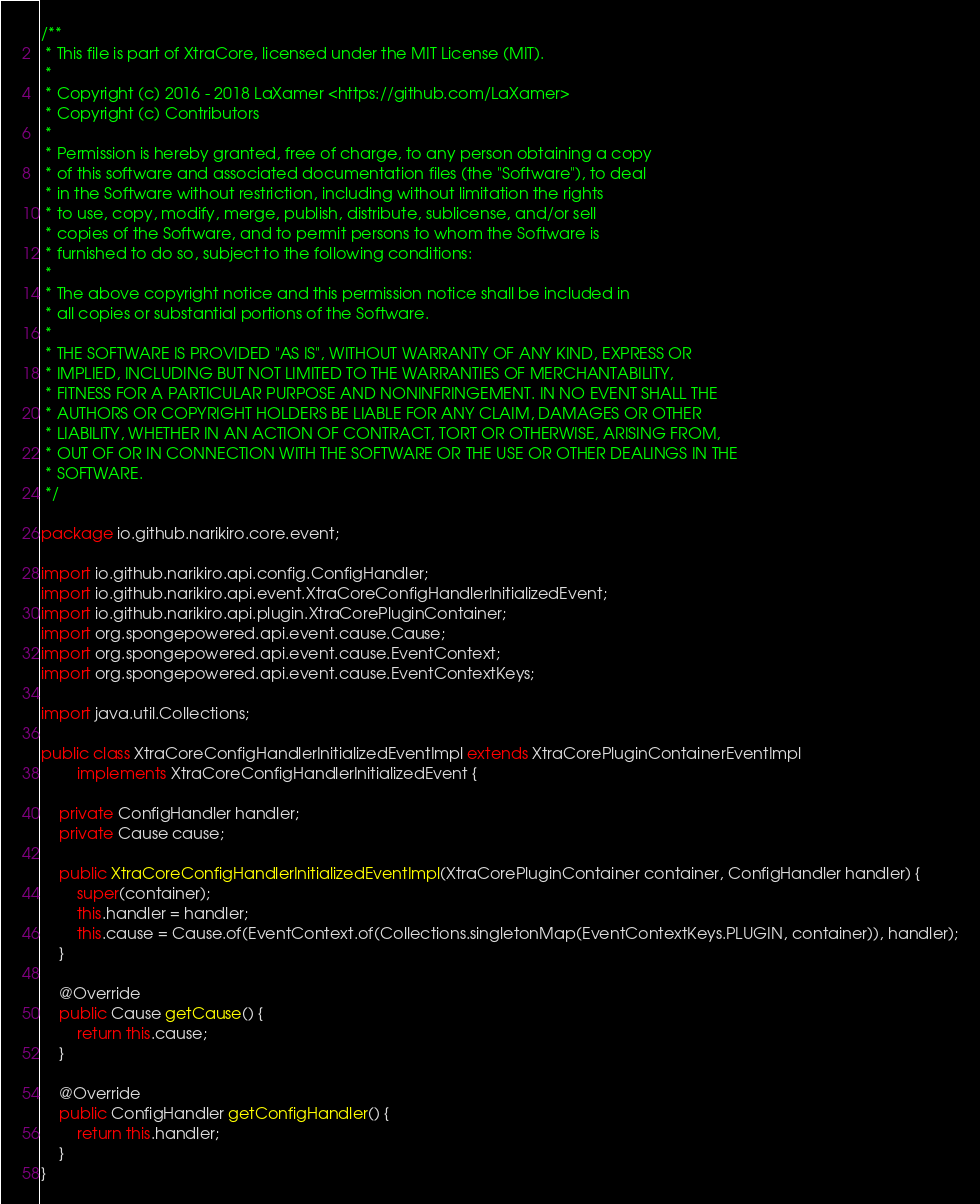Convert code to text. <code><loc_0><loc_0><loc_500><loc_500><_Java_>/**
 * This file is part of XtraCore, licensed under the MIT License (MIT).
 *
 * Copyright (c) 2016 - 2018 LaXamer <https://github.com/LaXamer>
 * Copyright (c) Contributors
 *
 * Permission is hereby granted, free of charge, to any person obtaining a copy
 * of this software and associated documentation files (the "Software"), to deal
 * in the Software without restriction, including without limitation the rights
 * to use, copy, modify, merge, publish, distribute, sublicense, and/or sell
 * copies of the Software, and to permit persons to whom the Software is
 * furnished to do so, subject to the following conditions:
 *
 * The above copyright notice and this permission notice shall be included in
 * all copies or substantial portions of the Software.
 *
 * THE SOFTWARE IS PROVIDED "AS IS", WITHOUT WARRANTY OF ANY KIND, EXPRESS OR
 * IMPLIED, INCLUDING BUT NOT LIMITED TO THE WARRANTIES OF MERCHANTABILITY,
 * FITNESS FOR A PARTICULAR PURPOSE AND NONINFRINGEMENT. IN NO EVENT SHALL THE
 * AUTHORS OR COPYRIGHT HOLDERS BE LIABLE FOR ANY CLAIM, DAMAGES OR OTHER
 * LIABILITY, WHETHER IN AN ACTION OF CONTRACT, TORT OR OTHERWISE, ARISING FROM,
 * OUT OF OR IN CONNECTION WITH THE SOFTWARE OR THE USE OR OTHER DEALINGS IN THE
 * SOFTWARE.
 */

package io.github.narikiro.core.event;

import io.github.narikiro.api.config.ConfigHandler;
import io.github.narikiro.api.event.XtraCoreConfigHandlerInitializedEvent;
import io.github.narikiro.api.plugin.XtraCorePluginContainer;
import org.spongepowered.api.event.cause.Cause;
import org.spongepowered.api.event.cause.EventContext;
import org.spongepowered.api.event.cause.EventContextKeys;

import java.util.Collections;

public class XtraCoreConfigHandlerInitializedEventImpl extends XtraCorePluginContainerEventImpl
        implements XtraCoreConfigHandlerInitializedEvent {

    private ConfigHandler handler;
    private Cause cause;

    public XtraCoreConfigHandlerInitializedEventImpl(XtraCorePluginContainer container, ConfigHandler handler) {
        super(container);
        this.handler = handler;
        this.cause = Cause.of(EventContext.of(Collections.singletonMap(EventContextKeys.PLUGIN, container)), handler);
    }

    @Override
    public Cause getCause() {
        return this.cause;
    }

    @Override
    public ConfigHandler getConfigHandler() {
        return this.handler;
    }
}
</code> 